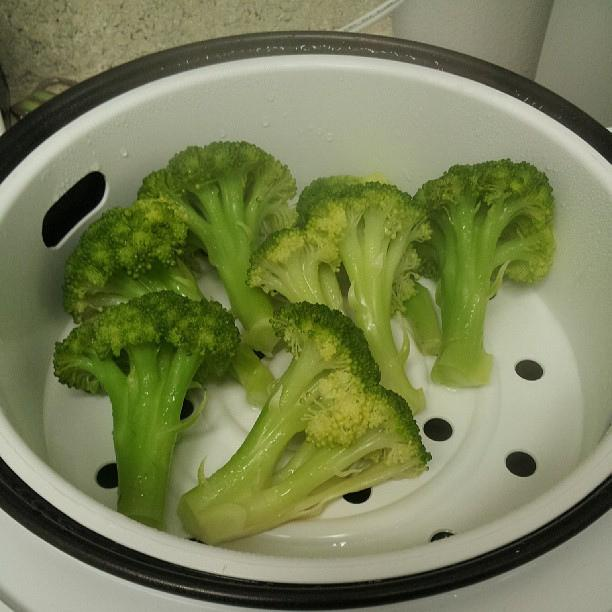What is the method being used to cook the broccoli? Please explain your reasoning. steam. The broccoli is in a basket that is used to steam veggies over boiling water. 